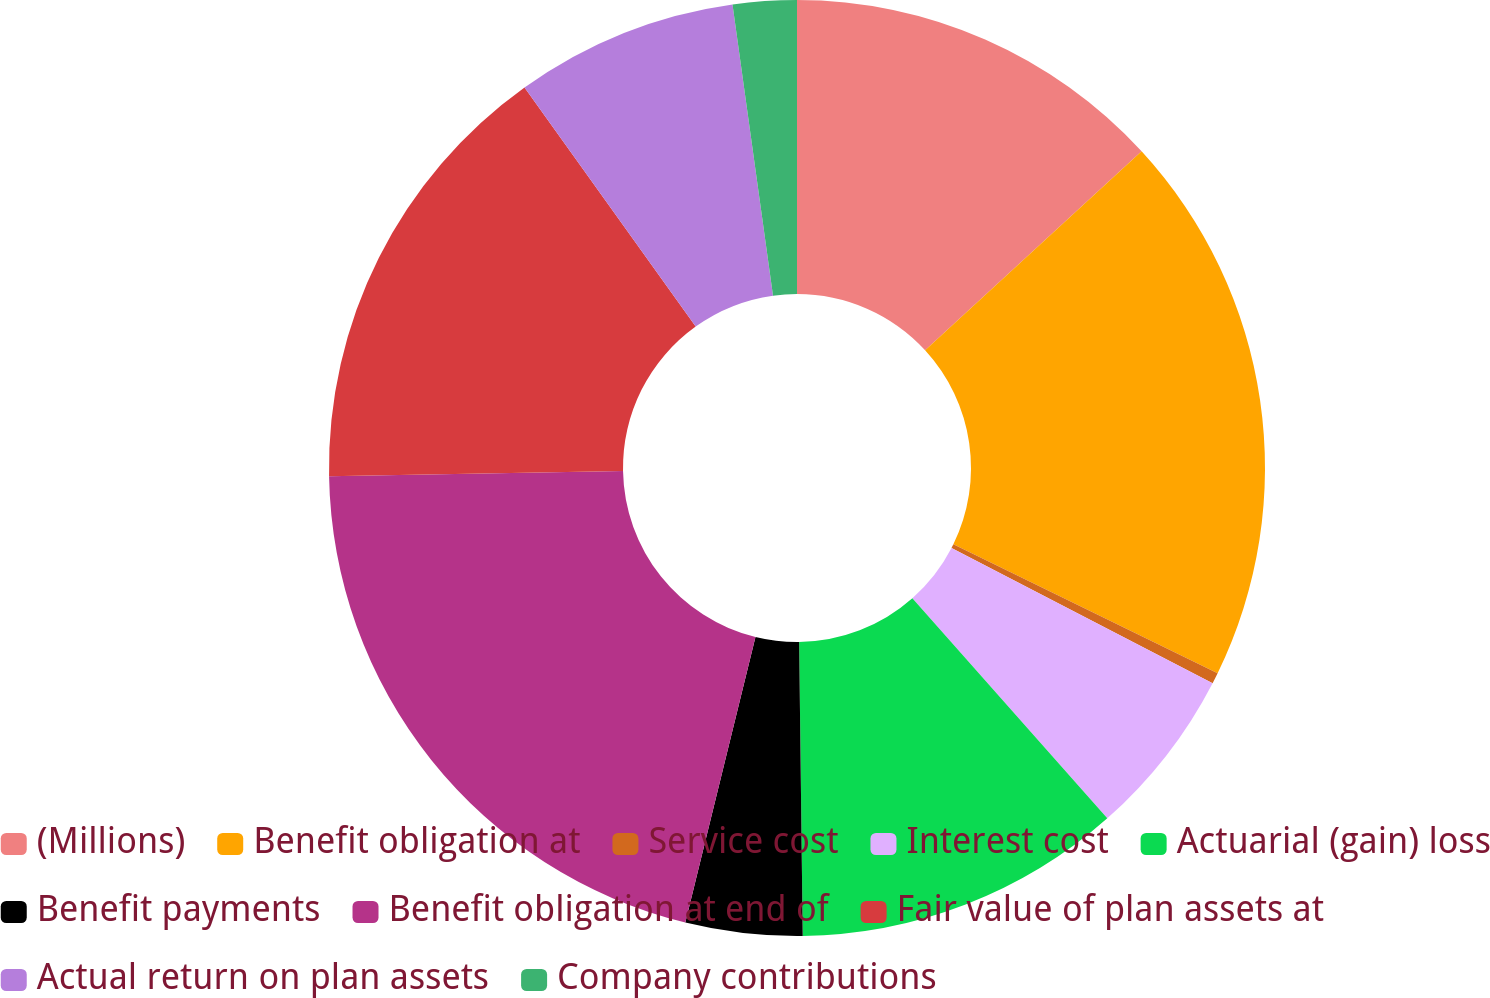<chart> <loc_0><loc_0><loc_500><loc_500><pie_chart><fcel>(Millions)<fcel>Benefit obligation at<fcel>Service cost<fcel>Interest cost<fcel>Actuarial (gain) loss<fcel>Benefit payments<fcel>Benefit obligation at end of<fcel>Fair value of plan assets at<fcel>Actual return on plan assets<fcel>Company contributions<nl><fcel>13.17%<fcel>19.05%<fcel>0.38%<fcel>5.86%<fcel>11.34%<fcel>4.03%<fcel>20.88%<fcel>15.39%<fcel>7.69%<fcel>2.2%<nl></chart> 